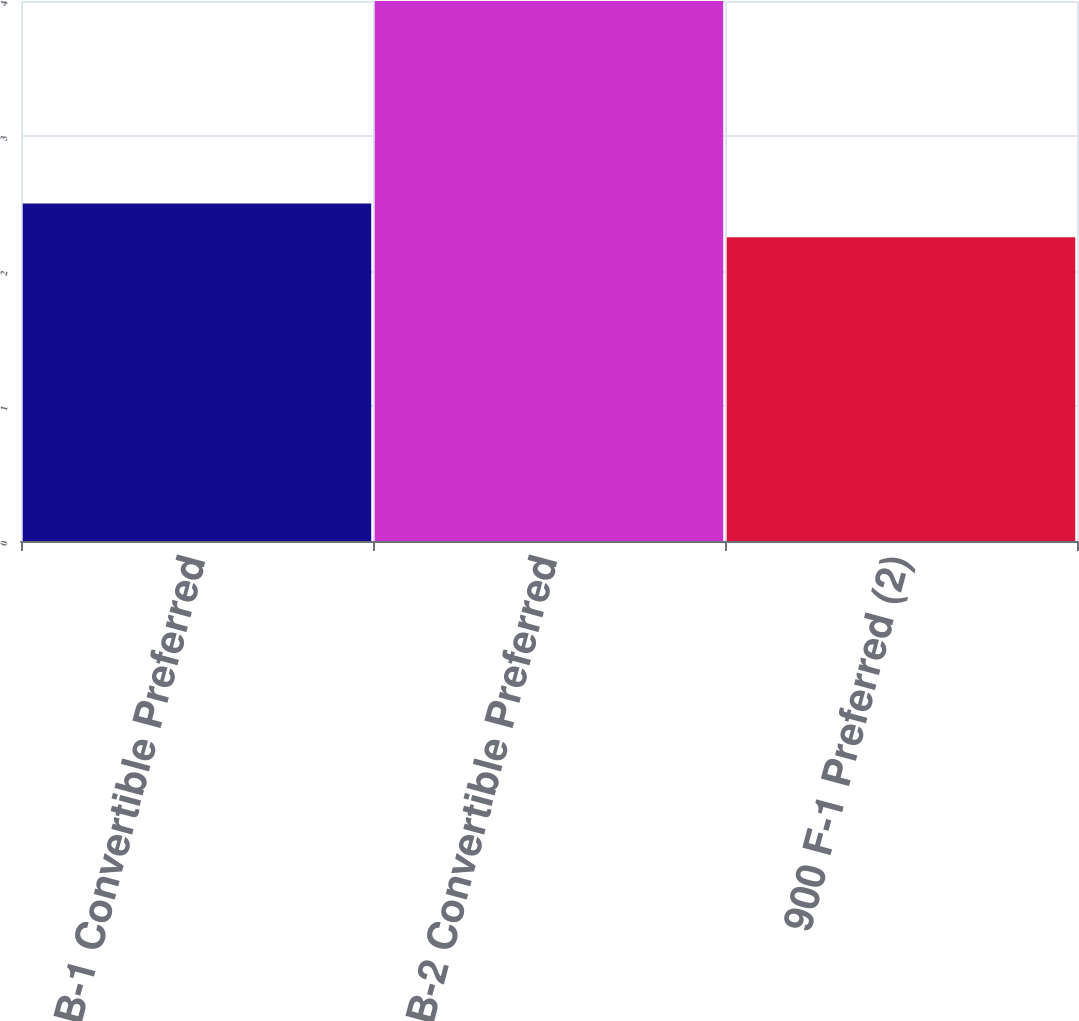Convert chart. <chart><loc_0><loc_0><loc_500><loc_500><bar_chart><fcel>500 B-1 Convertible Preferred<fcel>800 B-2 Convertible Preferred<fcel>900 F-1 Preferred (2)<nl><fcel>2.5<fcel>4<fcel>2.25<nl></chart> 